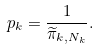<formula> <loc_0><loc_0><loc_500><loc_500>p _ { k } = \frac { 1 } { \widetilde { \pi } _ { k , N _ { k } } } .</formula> 